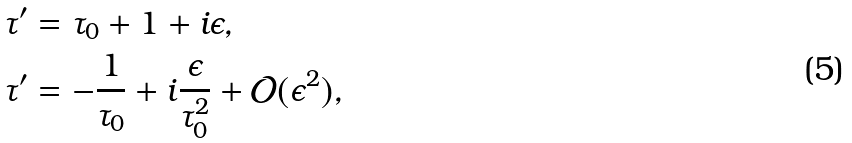<formula> <loc_0><loc_0><loc_500><loc_500>\tau ^ { \prime } & = \tau _ { 0 } + 1 + i \epsilon , \\ \tau ^ { \prime } & = - \frac { 1 } { \tau _ { 0 } } + i \frac { \epsilon } { \tau _ { 0 } ^ { 2 } } + \mathcal { O } ( \epsilon ^ { 2 } ) ,</formula> 